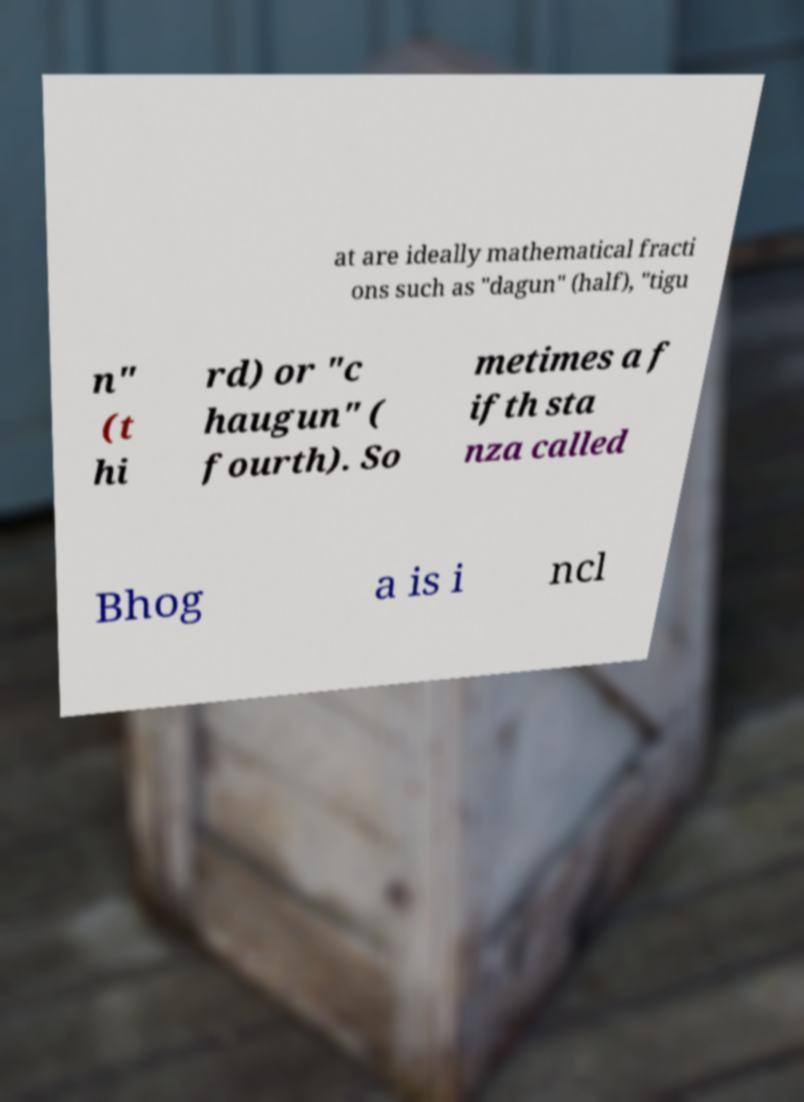I need the written content from this picture converted into text. Can you do that? at are ideally mathematical fracti ons such as "dagun" (half), "tigu n" (t hi rd) or "c haugun" ( fourth). So metimes a f ifth sta nza called Bhog a is i ncl 